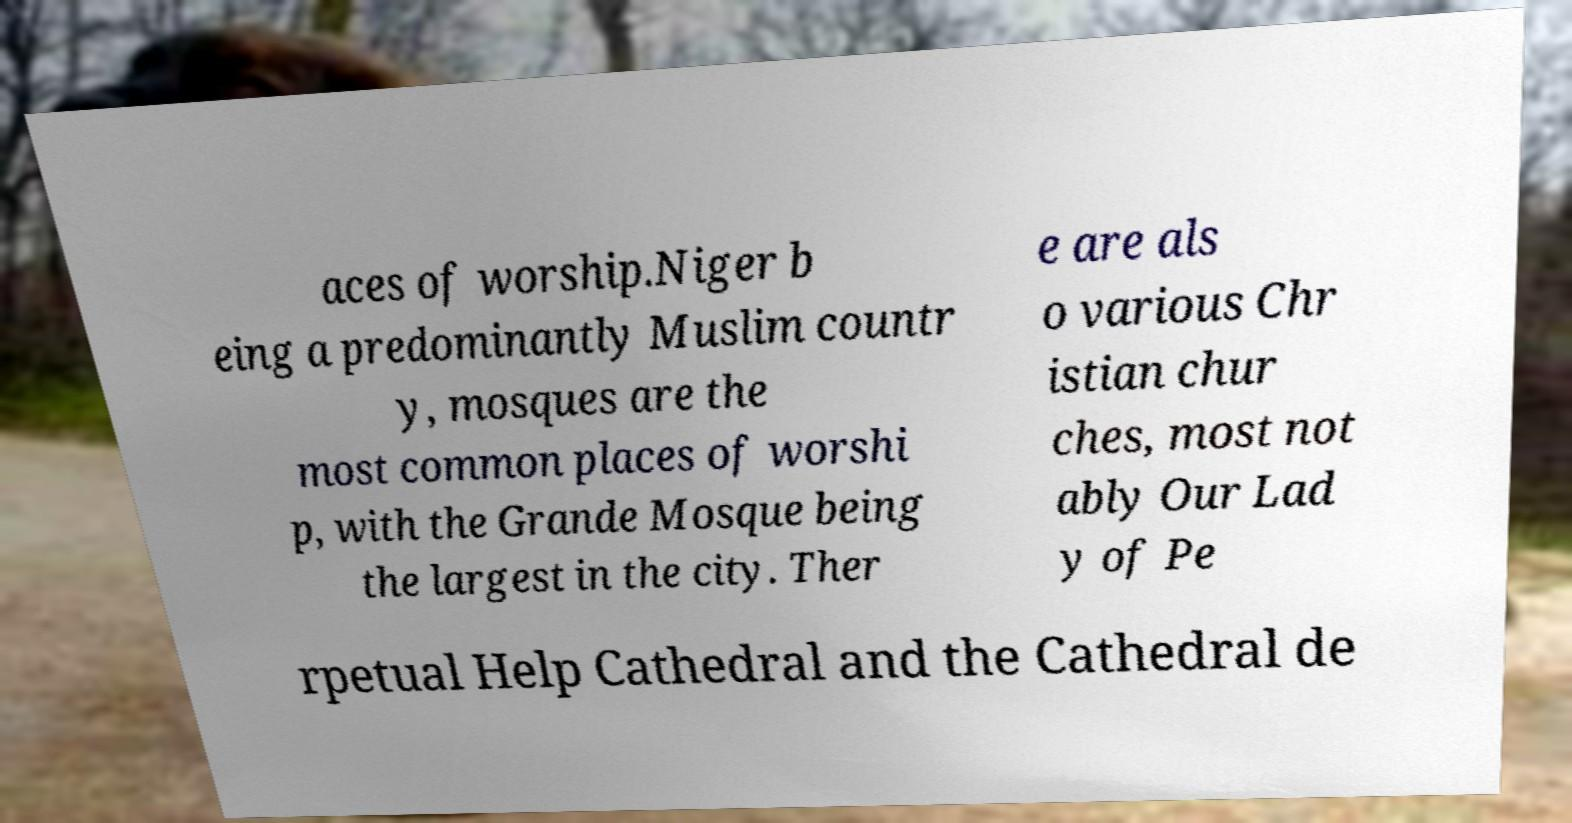For documentation purposes, I need the text within this image transcribed. Could you provide that? aces of worship.Niger b eing a predominantly Muslim countr y, mosques are the most common places of worshi p, with the Grande Mosque being the largest in the city. Ther e are als o various Chr istian chur ches, most not ably Our Lad y of Pe rpetual Help Cathedral and the Cathedral de 